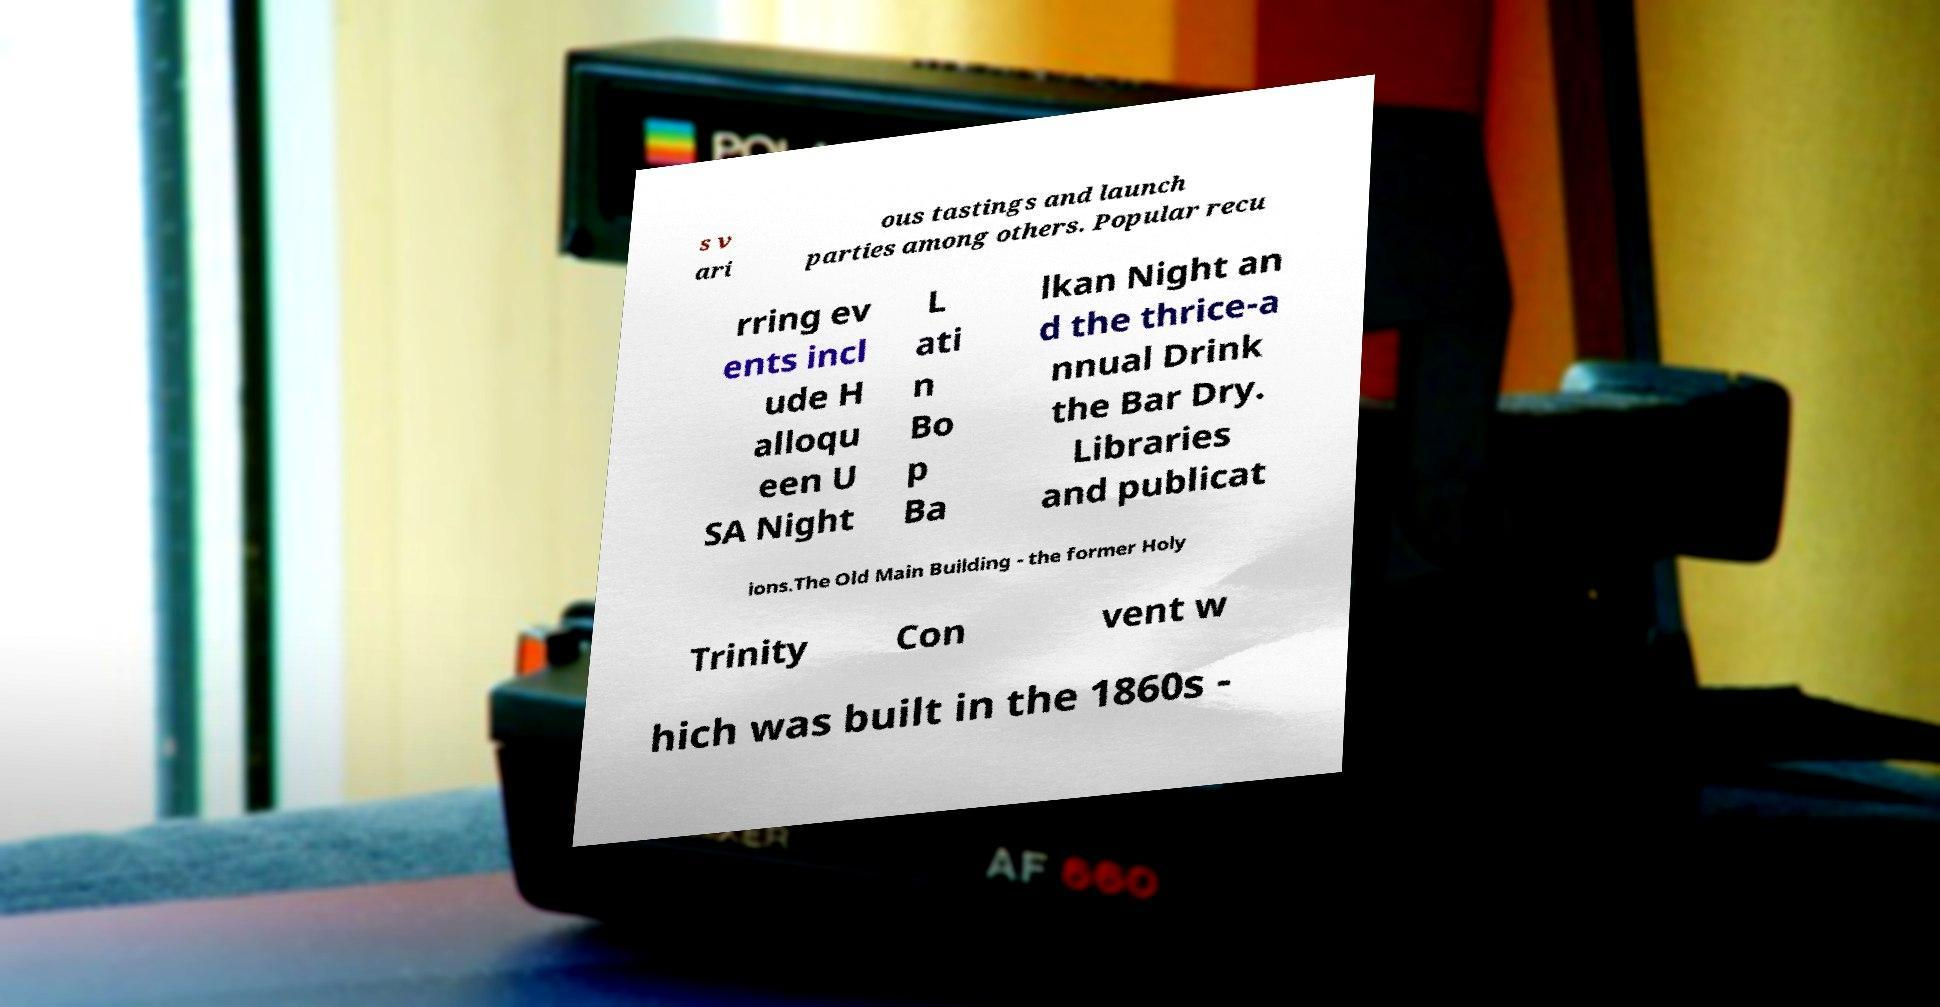Please read and relay the text visible in this image. What does it say? s v ari ous tastings and launch parties among others. Popular recu rring ev ents incl ude H alloqu een U SA Night L ati n Bo p Ba lkan Night an d the thrice-a nnual Drink the Bar Dry. Libraries and publicat ions.The Old Main Building - the former Holy Trinity Con vent w hich was built in the 1860s - 